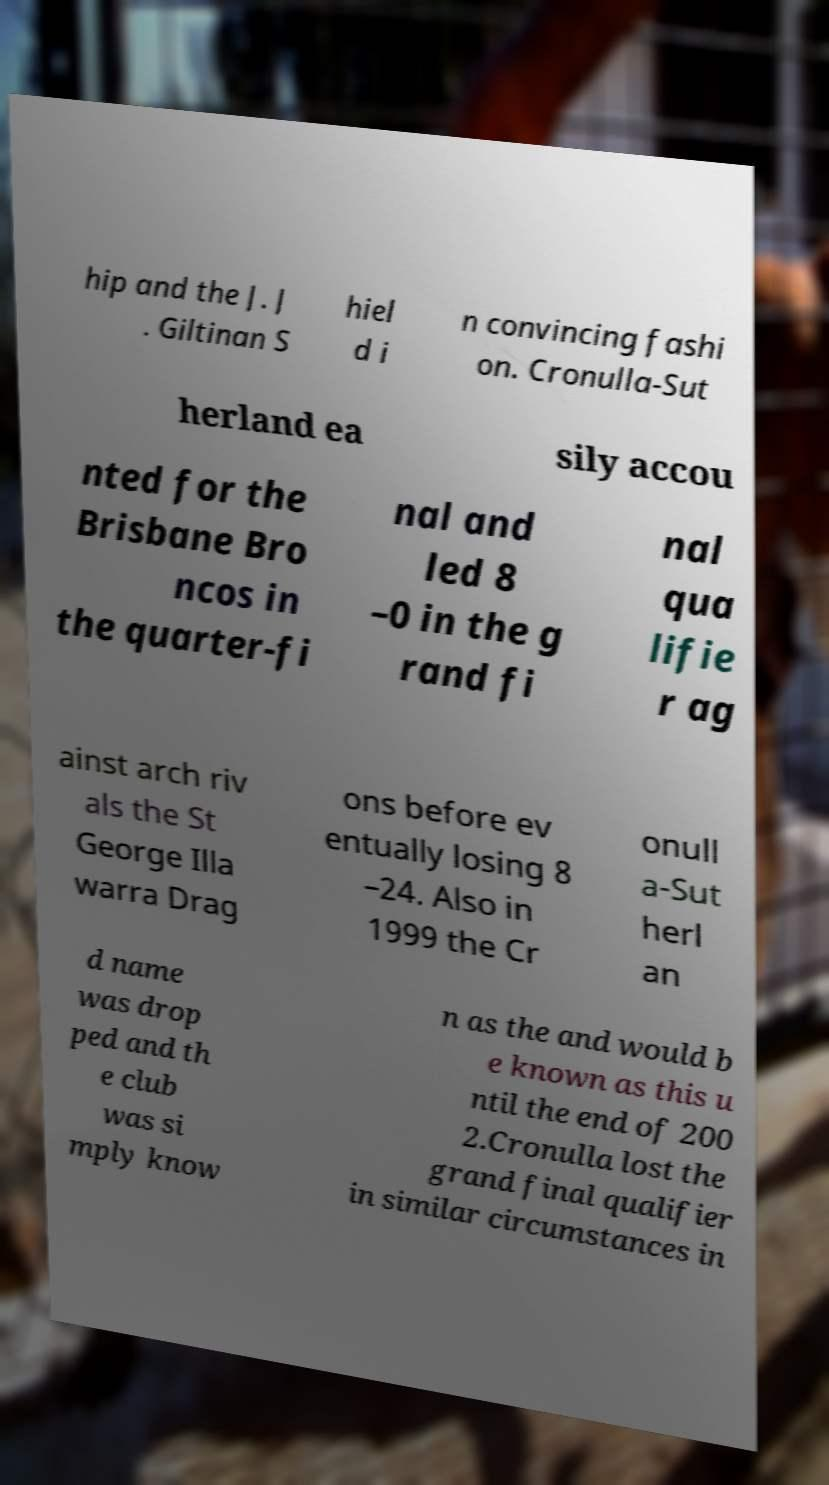Can you accurately transcribe the text from the provided image for me? hip and the J. J . Giltinan S hiel d i n convincing fashi on. Cronulla-Sut herland ea sily accou nted for the Brisbane Bro ncos in the quarter-fi nal and led 8 –0 in the g rand fi nal qua lifie r ag ainst arch riv als the St George Illa warra Drag ons before ev entually losing 8 –24. Also in 1999 the Cr onull a-Sut herl an d name was drop ped and th e club was si mply know n as the and would b e known as this u ntil the end of 200 2.Cronulla lost the grand final qualifier in similar circumstances in 